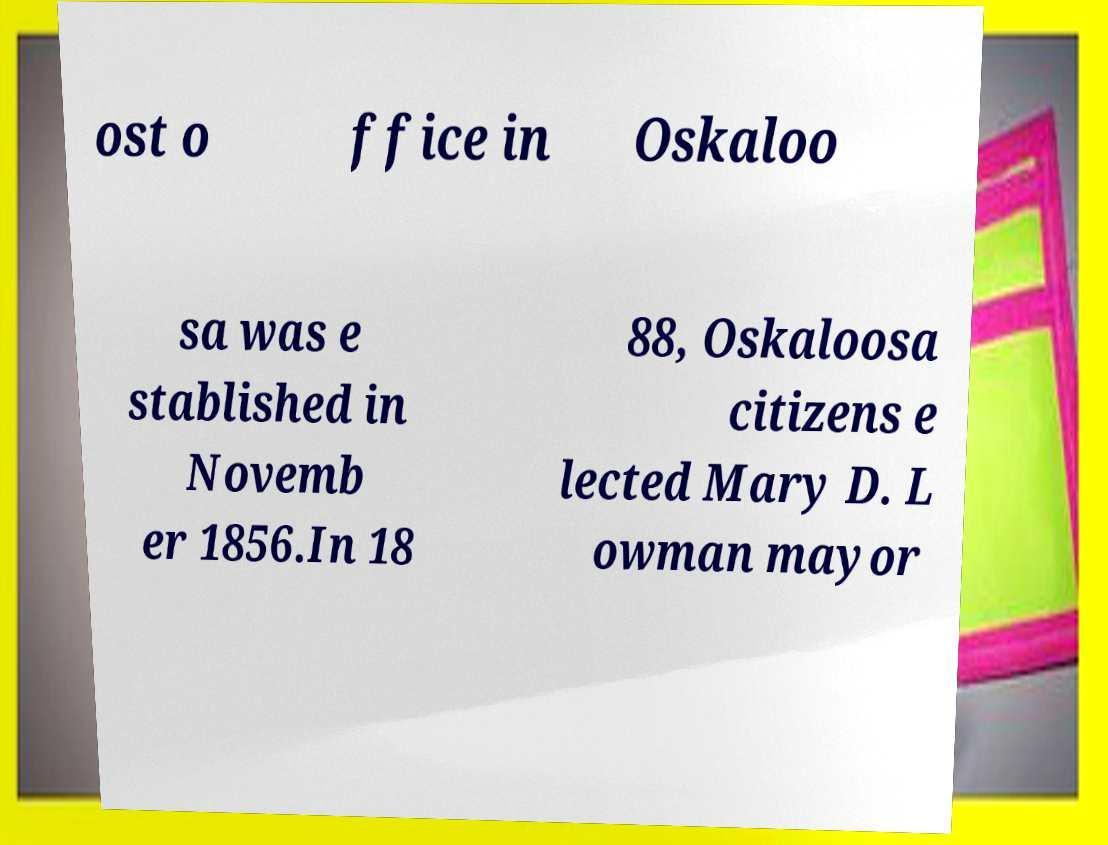For documentation purposes, I need the text within this image transcribed. Could you provide that? ost o ffice in Oskaloo sa was e stablished in Novemb er 1856.In 18 88, Oskaloosa citizens e lected Mary D. L owman mayor 